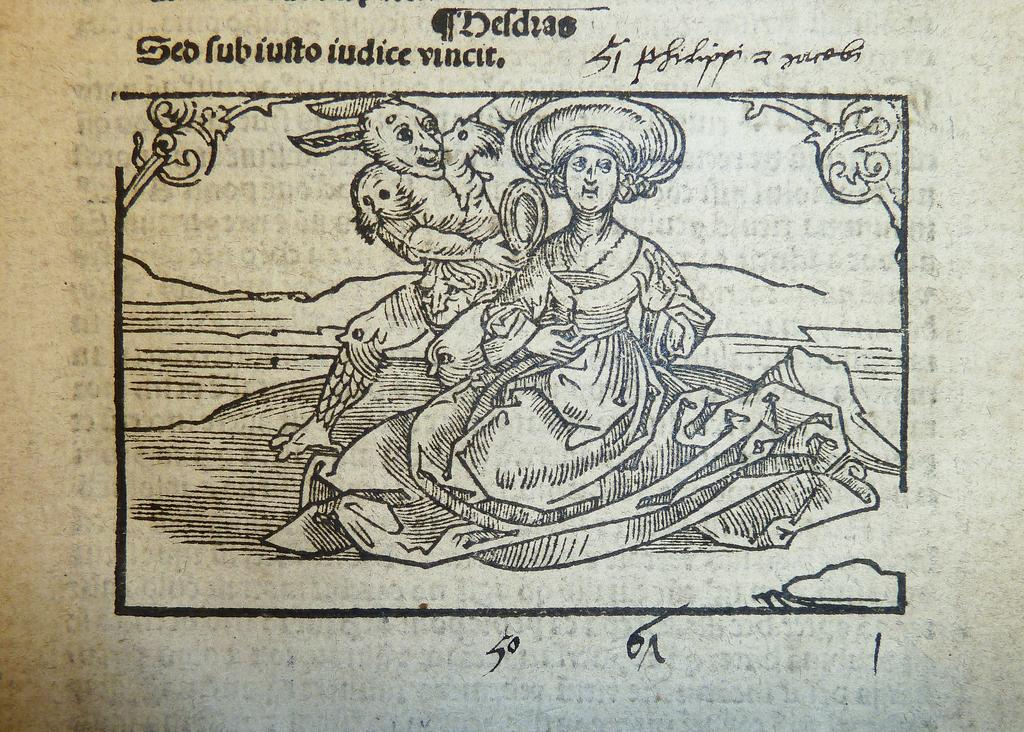What is present in the image that contains visuals and text? There is a poster in the image that contains pictures and text. Can you describe the content of the poster? The poster contains pictures and text, but the specific content cannot be determined from the provided facts. What type of thread is used to hold the toothpaste on the poster? There is no toothpaste or thread present on the poster in the image. 